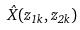Convert formula to latex. <formula><loc_0><loc_0><loc_500><loc_500>\hat { X } ( z _ { 1 k } , z _ { 2 k } )</formula> 